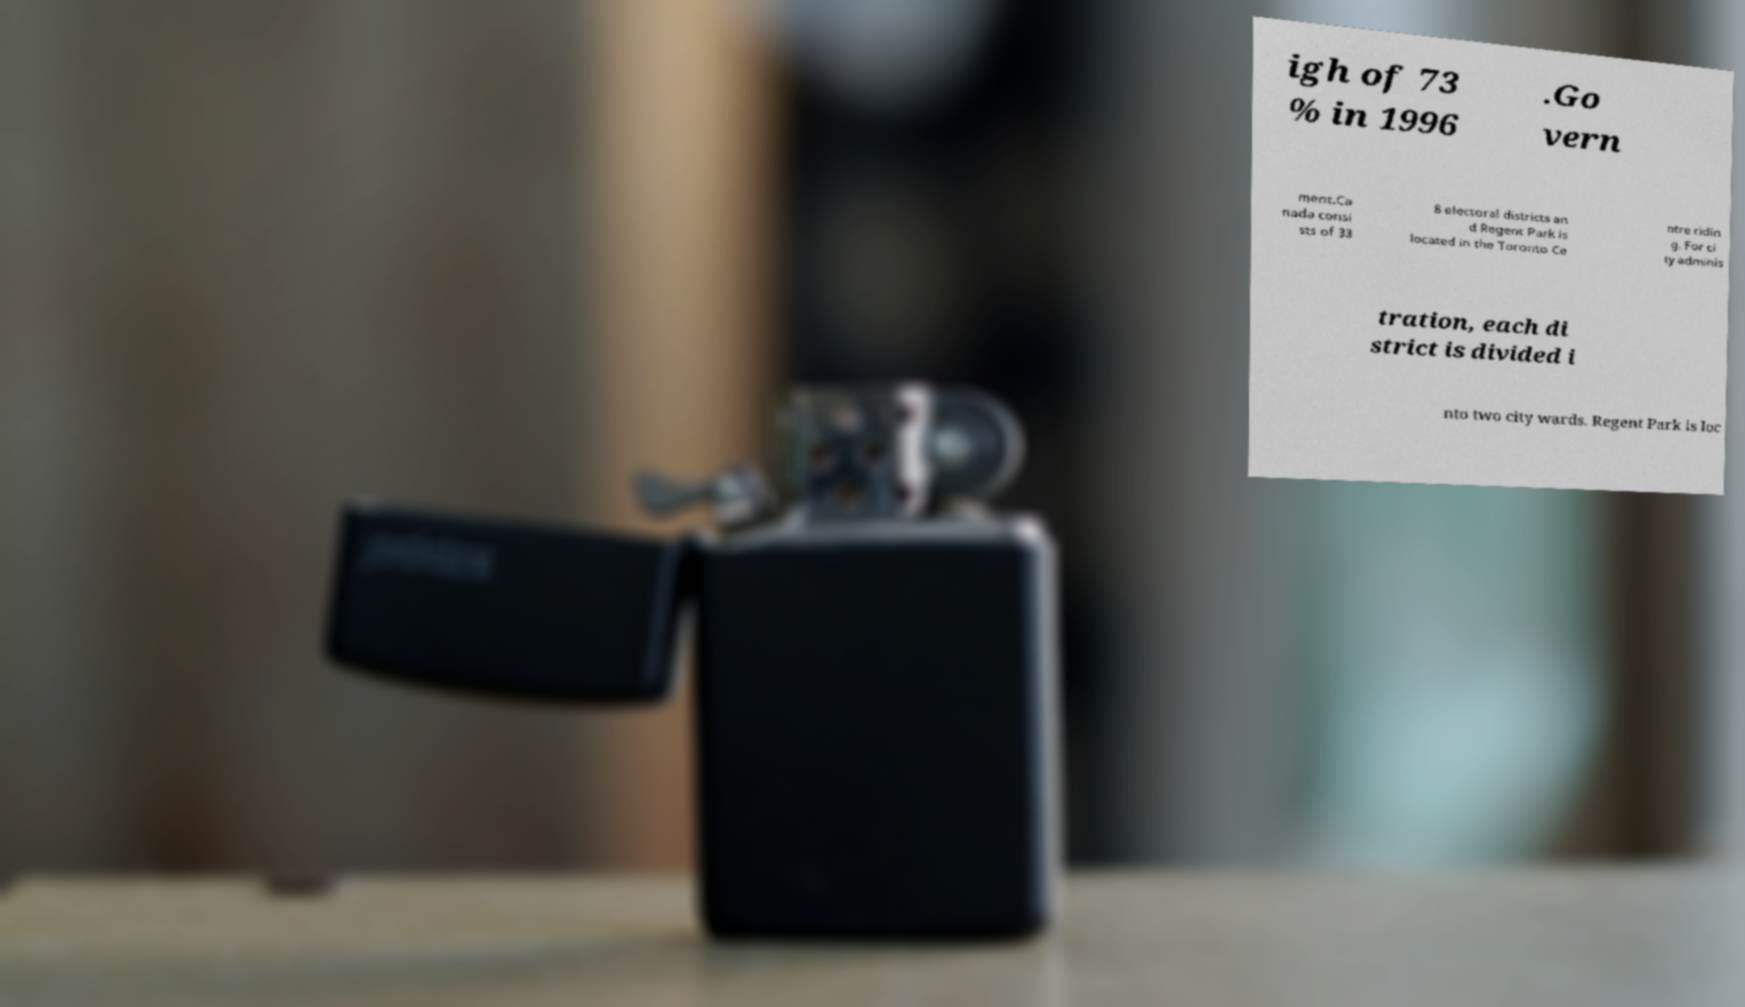Please read and relay the text visible in this image. What does it say? igh of 73 % in 1996 .Go vern ment.Ca nada consi sts of 33 8 electoral districts an d Regent Park is located in the Toronto Ce ntre ridin g. For ci ty adminis tration, each di strict is divided i nto two city wards. Regent Park is loc 